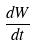Convert formula to latex. <formula><loc_0><loc_0><loc_500><loc_500>\frac { d W } { d t }</formula> 